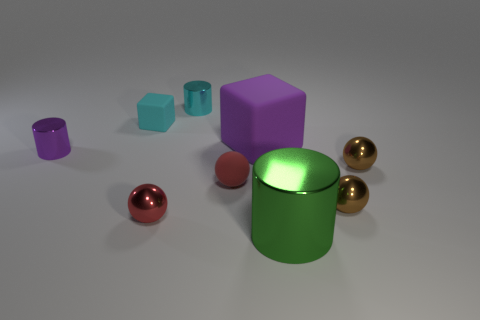There is a metal cylinder that is both behind the red matte sphere and in front of the tiny matte cube; what is its color?
Keep it short and to the point. Purple. What is the shape of the tiny red object that is the same material as the large green cylinder?
Provide a short and direct response. Sphere. How many things are both in front of the red rubber thing and on the right side of the green thing?
Your answer should be very brief. 1. Are there any small shiny things on the left side of the small matte ball?
Provide a succinct answer. Yes. Is the shape of the big green metallic object that is in front of the cyan cylinder the same as the small rubber thing in front of the big purple matte block?
Offer a terse response. No. How many objects are either large brown rubber objects or things in front of the large matte object?
Offer a terse response. 6. What number of other things are the same shape as the green object?
Ensure brevity in your answer.  2. Is the material of the tiny cylinder in front of the large matte block the same as the big cylinder?
Provide a short and direct response. Yes. What number of objects are shiny cylinders or small red shiny objects?
Offer a very short reply. 4. There is a purple object that is the same shape as the cyan metallic thing; what size is it?
Provide a succinct answer. Small. 